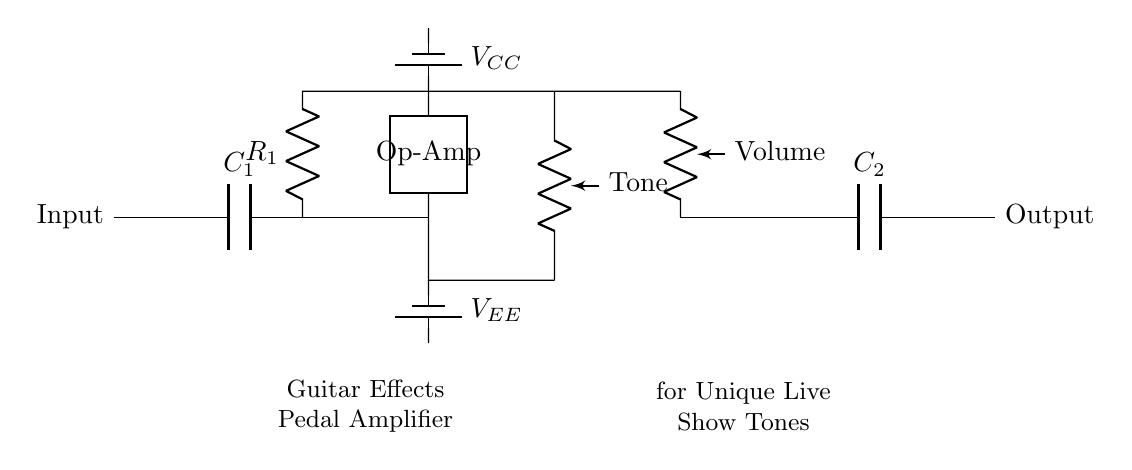What is the type of the first component in the circuit? The first component in the circuit is a capacitor, labeled as C1, which is used to filter high-frequency noise from the guitar signal.
Answer: Capacitor What is the role of the potentiometer in this circuit? The potentiometer labeled as "Tone" controls the tonal quality of the signal by adjusting the frequency response, while the other potentiometer "Volume" adjusts the output level, allowing the artist to shape their sound during performances.
Answer: Tone control How many batteries are present in the circuit? There are two batteries in the circuit: one labeled as VCC providing positive voltage and the other as VEE providing negative voltage for the op-amp's operation to ensure proper amplification of the guitar signal.
Answer: Two batteries What component type is used to amplify the signal in this circuit? The signal is amplified by an operational amplifier (op-amp) which is a critical component in audio signal amplification, enhancing the guitar sound for better projection during live shows.
Answer: Op-Amp What does circuit label "Output" indicate? The label "Output" indicates the point where the amplified and processed guitar signal exits the circuit, ready to be sent to speakers or further effects, crucial for live performances to achieve the desired sound.
Answer: Output What is the function of capacitor C2 in this circuit? Capacitor C2 is part of the output stage which blocks any DC voltage from the amplifier, allowing only the AC guitar signal to pass through to the output, ensuring that the connected devices receive the correct signal type for optimal sound clarity.
Answer: Block DC voltage 